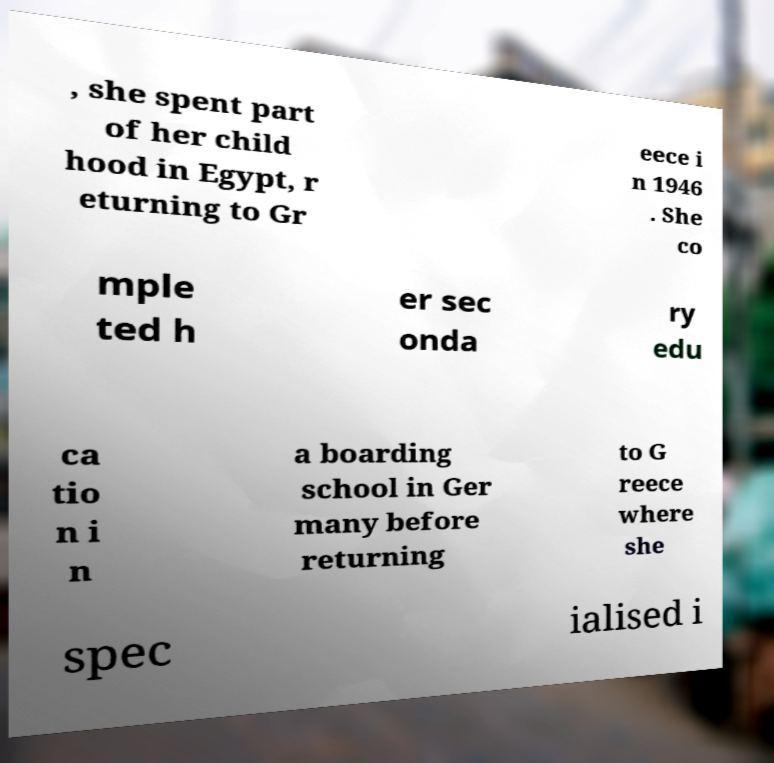For documentation purposes, I need the text within this image transcribed. Could you provide that? , she spent part of her child hood in Egypt, r eturning to Gr eece i n 1946 . She co mple ted h er sec onda ry edu ca tio n i n a boarding school in Ger many before returning to G reece where she spec ialised i 